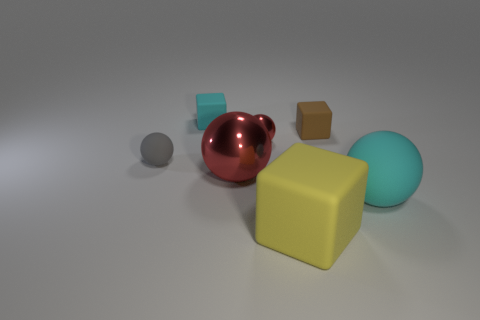What is the size of the shiny object that is the same color as the tiny metal sphere?
Make the answer very short. Large. Is there a red metallic sphere of the same size as the cyan rubber ball?
Your answer should be very brief. Yes. Is the large red object made of the same material as the large cyan object that is in front of the tiny gray rubber sphere?
Offer a terse response. No. Are there more red metallic blocks than small red metallic things?
Offer a very short reply. No. What number of spheres are either small brown matte objects or large red objects?
Your answer should be compact. 1. What is the color of the tiny rubber ball?
Make the answer very short. Gray. There is a cube that is to the left of the yellow rubber object; is its size the same as the yellow rubber thing in front of the big red metallic sphere?
Provide a succinct answer. No. Is the number of tiny purple metal objects less than the number of tiny gray spheres?
Keep it short and to the point. Yes. There is a gray ball; how many big rubber spheres are behind it?
Make the answer very short. 0. What material is the brown block?
Your answer should be very brief. Rubber. 